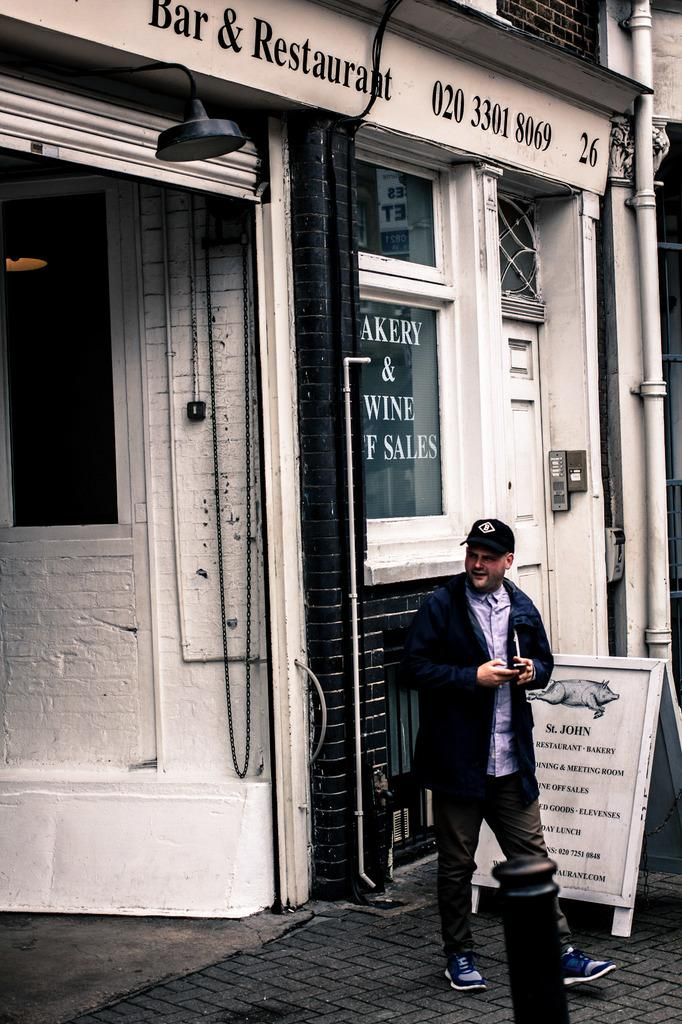What is the main subject in front of the store in the image? There is a person in front of a store in the image. What is located beside the person? There is a board beside the person. How many kittens are playing with the blade on the board in the image? There are no kittens or blades present in the image. Is there a lawyer standing next to the person in the image? There is no mention of a lawyer in the image. 